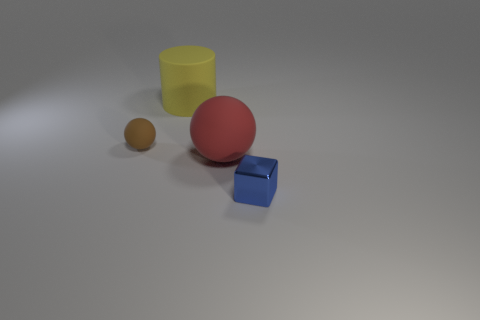Add 1 small brown spheres. How many objects exist? 5 Subtract all brown balls. How many balls are left? 1 Subtract 1 blocks. How many blocks are left? 0 Subtract all cyan cylinders. Subtract all brown cubes. How many cylinders are left? 1 Add 3 yellow things. How many yellow things exist? 4 Subtract 0 blue spheres. How many objects are left? 4 Subtract all cylinders. How many objects are left? 3 Subtract all small gray shiny objects. Subtract all large spheres. How many objects are left? 3 Add 4 large matte things. How many large matte things are left? 6 